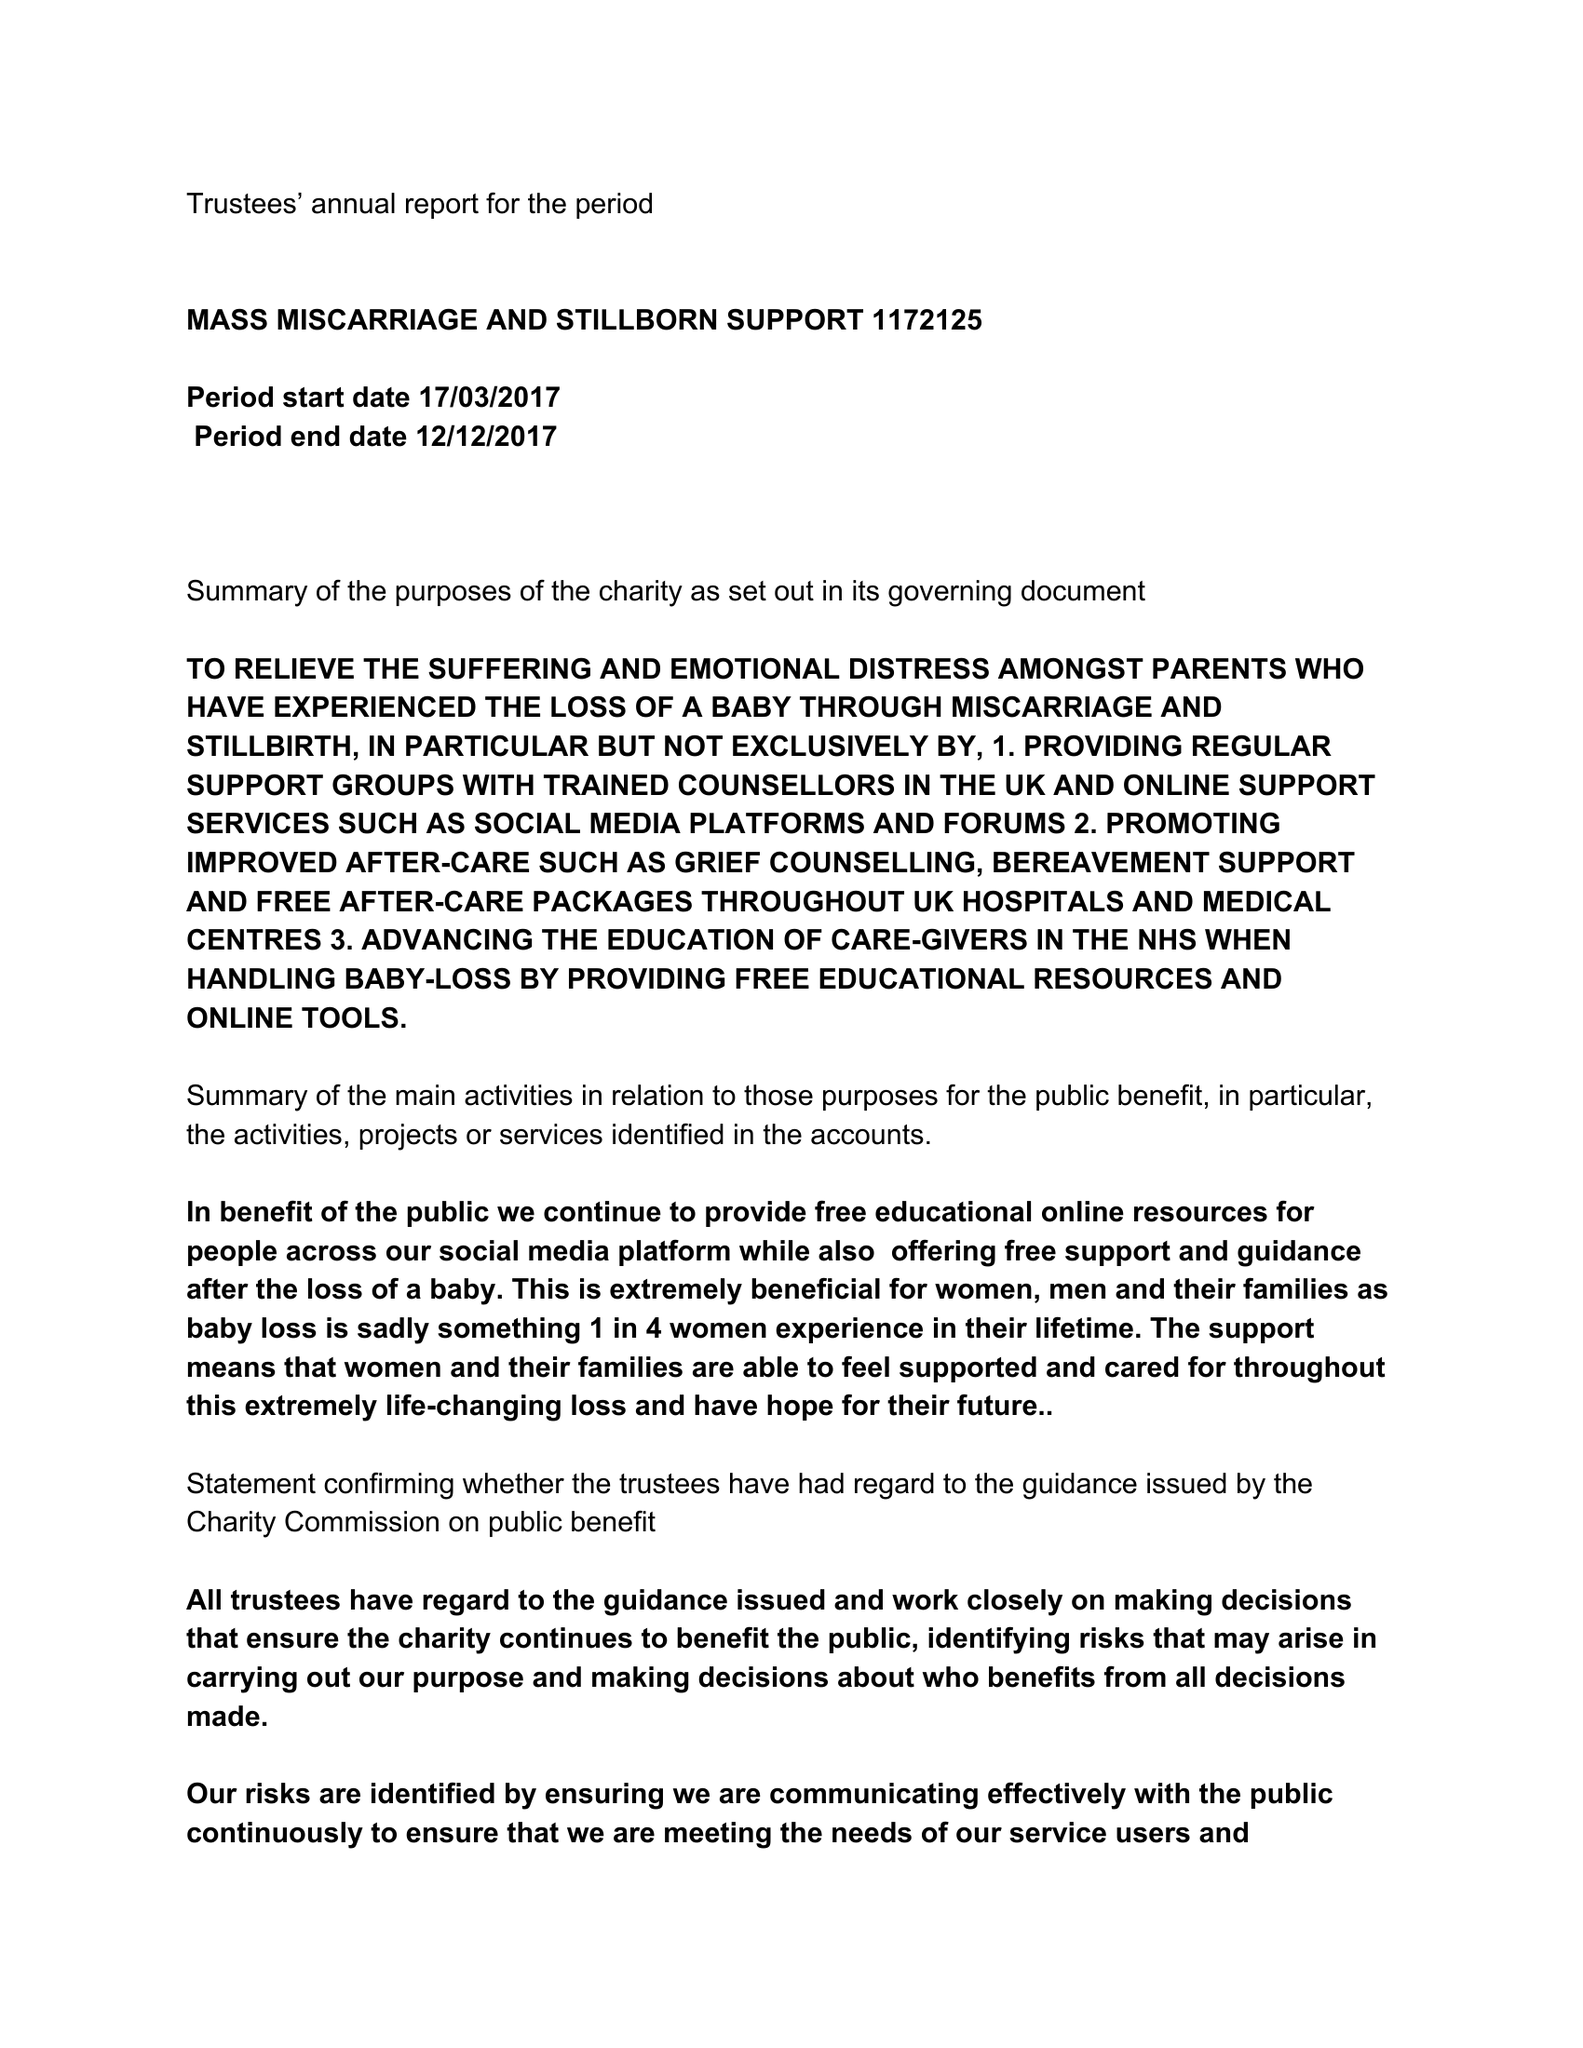What is the value for the address__postcode?
Answer the question using a single word or phrase. MK42 0DX 